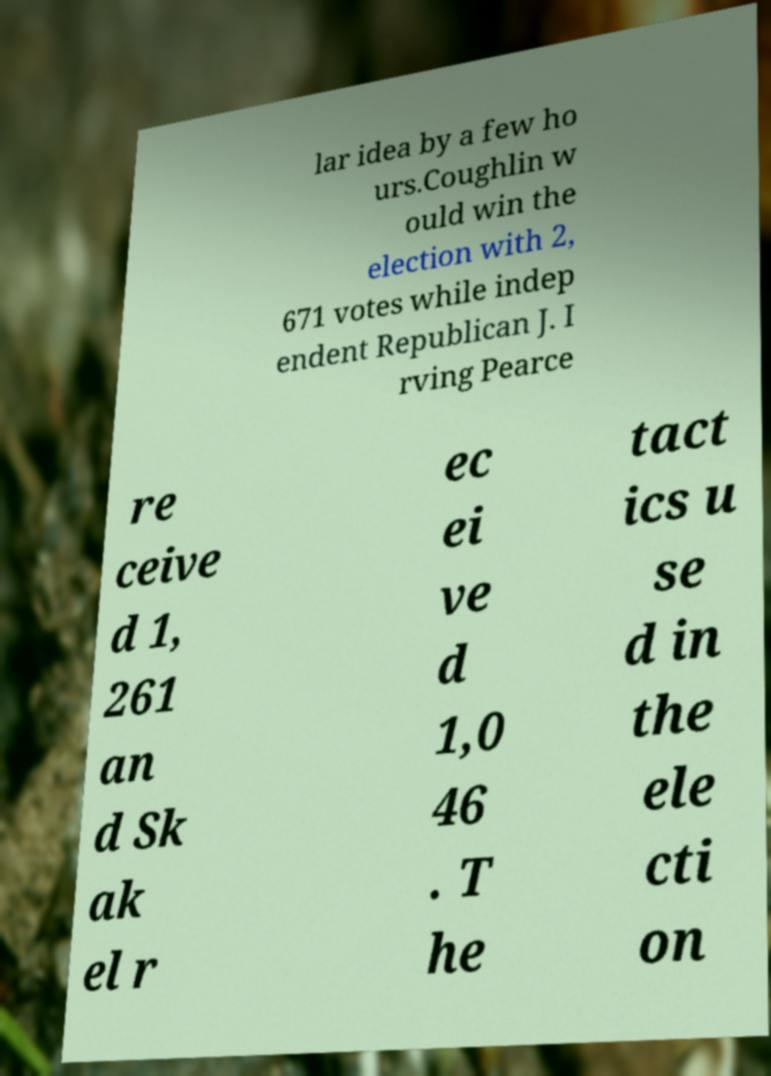Can you accurately transcribe the text from the provided image for me? lar idea by a few ho urs.Coughlin w ould win the election with 2, 671 votes while indep endent Republican J. I rving Pearce re ceive d 1, 261 an d Sk ak el r ec ei ve d 1,0 46 . T he tact ics u se d in the ele cti on 